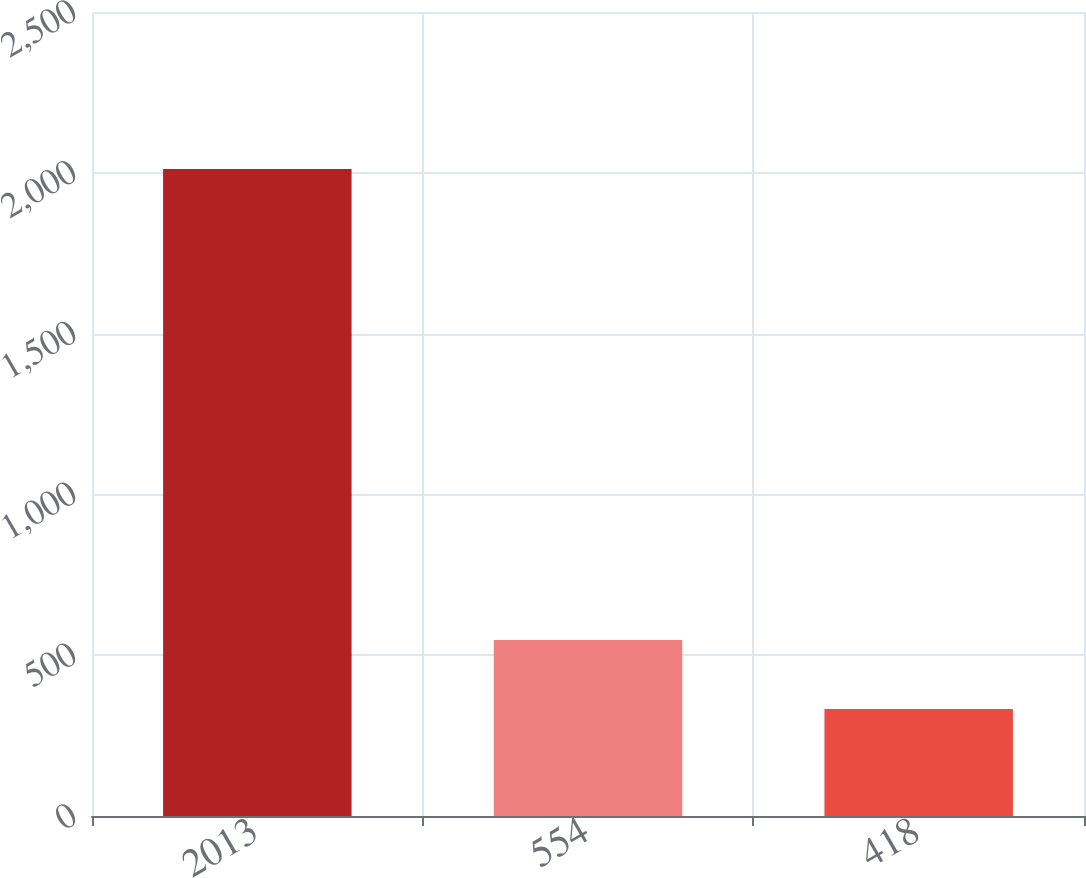<chart> <loc_0><loc_0><loc_500><loc_500><bar_chart><fcel>2013<fcel>554<fcel>418<nl><fcel>2012<fcel>547<fcel>333<nl></chart> 